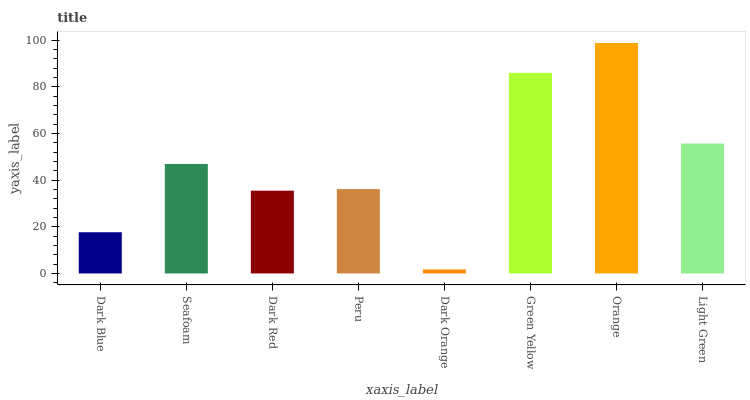Is Dark Orange the minimum?
Answer yes or no. Yes. Is Orange the maximum?
Answer yes or no. Yes. Is Seafoam the minimum?
Answer yes or no. No. Is Seafoam the maximum?
Answer yes or no. No. Is Seafoam greater than Dark Blue?
Answer yes or no. Yes. Is Dark Blue less than Seafoam?
Answer yes or no. Yes. Is Dark Blue greater than Seafoam?
Answer yes or no. No. Is Seafoam less than Dark Blue?
Answer yes or no. No. Is Seafoam the high median?
Answer yes or no. Yes. Is Peru the low median?
Answer yes or no. Yes. Is Dark Blue the high median?
Answer yes or no. No. Is Dark Red the low median?
Answer yes or no. No. 